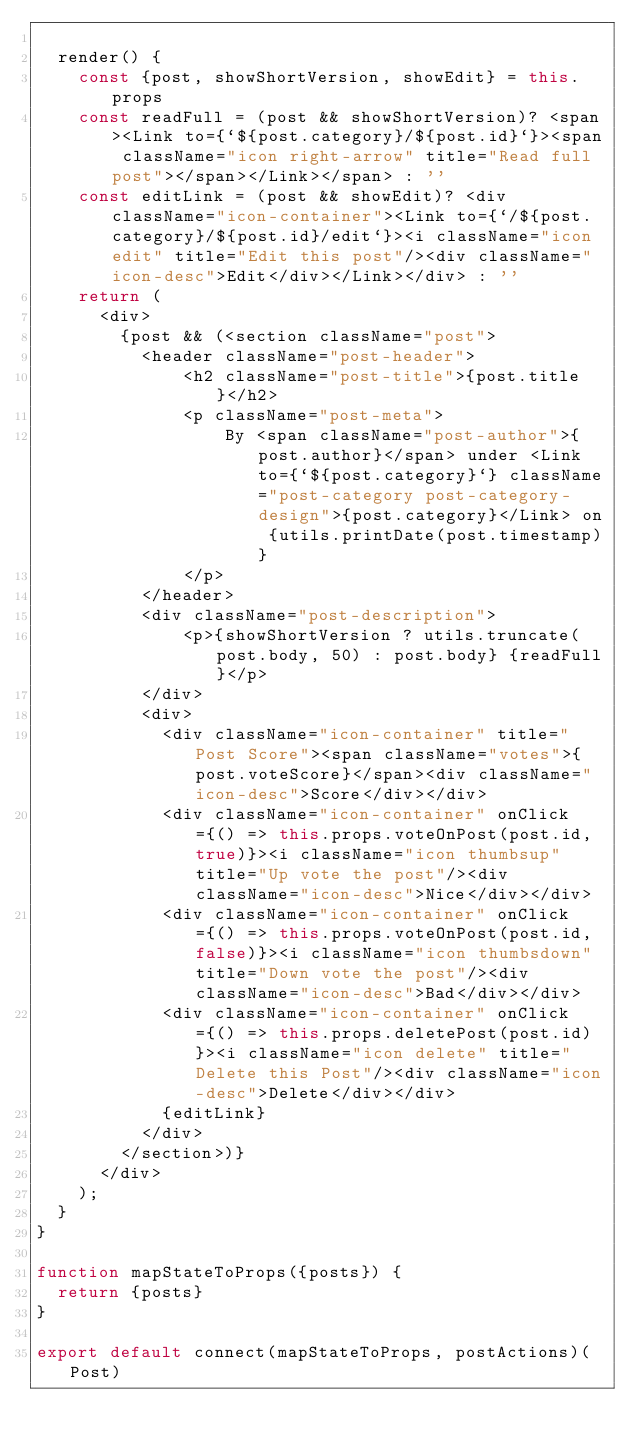<code> <loc_0><loc_0><loc_500><loc_500><_JavaScript_>
  render() {
    const {post, showShortVersion, showEdit} = this.props
    const readFull = (post && showShortVersion)? <span><Link to={`${post.category}/${post.id}`}><span className="icon right-arrow" title="Read full post"></span></Link></span> : ''
    const editLink = (post && showEdit)? <div className="icon-container"><Link to={`/${post.category}/${post.id}/edit`}><i className="icon edit" title="Edit this post"/><div className="icon-desc">Edit</div></Link></div> : ''
    return (
      <div>
        {post && (<section className="post">
          <header className="post-header">
              <h2 className="post-title">{post.title}</h2>
              <p className="post-meta">
                  By <span className="post-author">{post.author}</span> under <Link to={`${post.category}`} className="post-category post-category-design">{post.category}</Link> on {utils.printDate(post.timestamp)}
              </p>
          </header>
          <div className="post-description">
              <p>{showShortVersion ? utils.truncate(post.body, 50) : post.body} {readFull}</p>
          </div>
          <div>
            <div className="icon-container" title="Post Score"><span className="votes">{post.voteScore}</span><div className="icon-desc">Score</div></div>
            <div className="icon-container" onClick={() => this.props.voteOnPost(post.id, true)}><i className="icon thumbsup" title="Up vote the post"/><div className="icon-desc">Nice</div></div>
            <div className="icon-container" onClick={() => this.props.voteOnPost(post.id, false)}><i className="icon thumbsdown" title="Down vote the post"/><div className="icon-desc">Bad</div></div>
            <div className="icon-container" onClick={() => this.props.deletePost(post.id)}><i className="icon delete" title="Delete this Post"/><div className="icon-desc">Delete</div></div>
            {editLink}
          </div>
        </section>)}
      </div>
    );
  }
}

function mapStateToProps({posts}) {
  return {posts}
}

export default connect(mapStateToProps, postActions)(Post)
</code> 